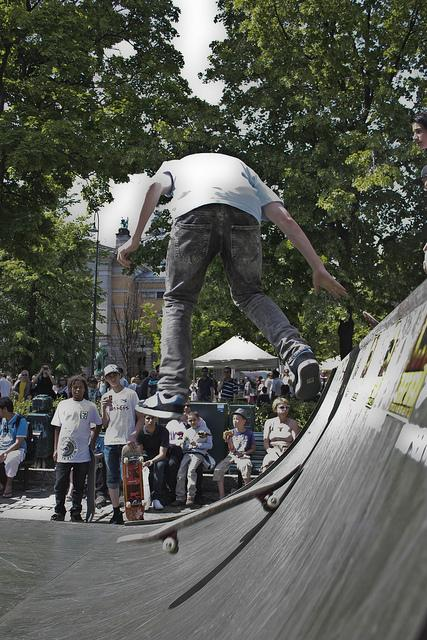Why is he in the air above the skateboard?

Choices:
A) bouncing
B) showing off
C) confused
D) falling showing off 